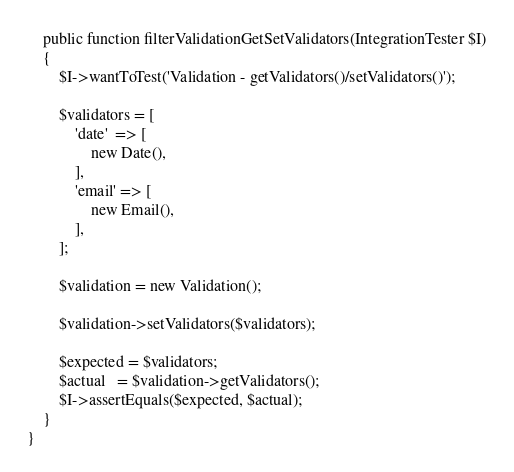Convert code to text. <code><loc_0><loc_0><loc_500><loc_500><_PHP_>    public function filterValidationGetSetValidators(IntegrationTester $I)
    {
        $I->wantToTest('Validation - getValidators()/setValidators()');

        $validators = [
            'date'  => [
                new Date(),
            ],
            'email' => [
                new Email(),
            ],
        ];

        $validation = new Validation();

        $validation->setValidators($validators);

        $expected = $validators;
        $actual   = $validation->getValidators();
        $I->assertEquals($expected, $actual);
    }
}
</code> 